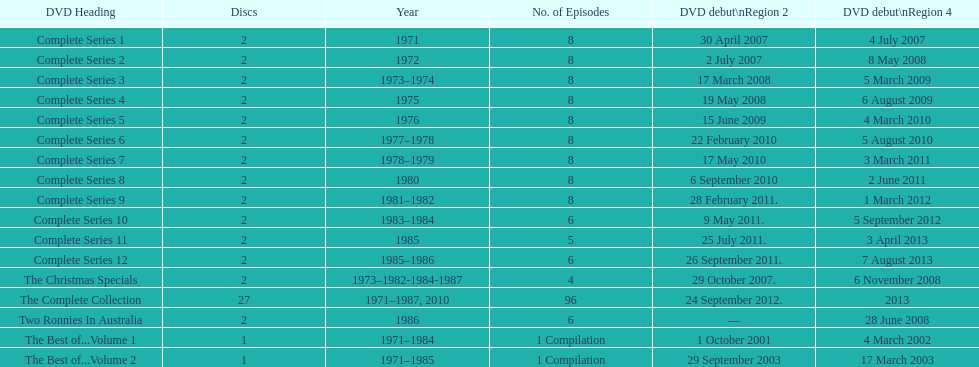How many series had 8 episodes? 9. 